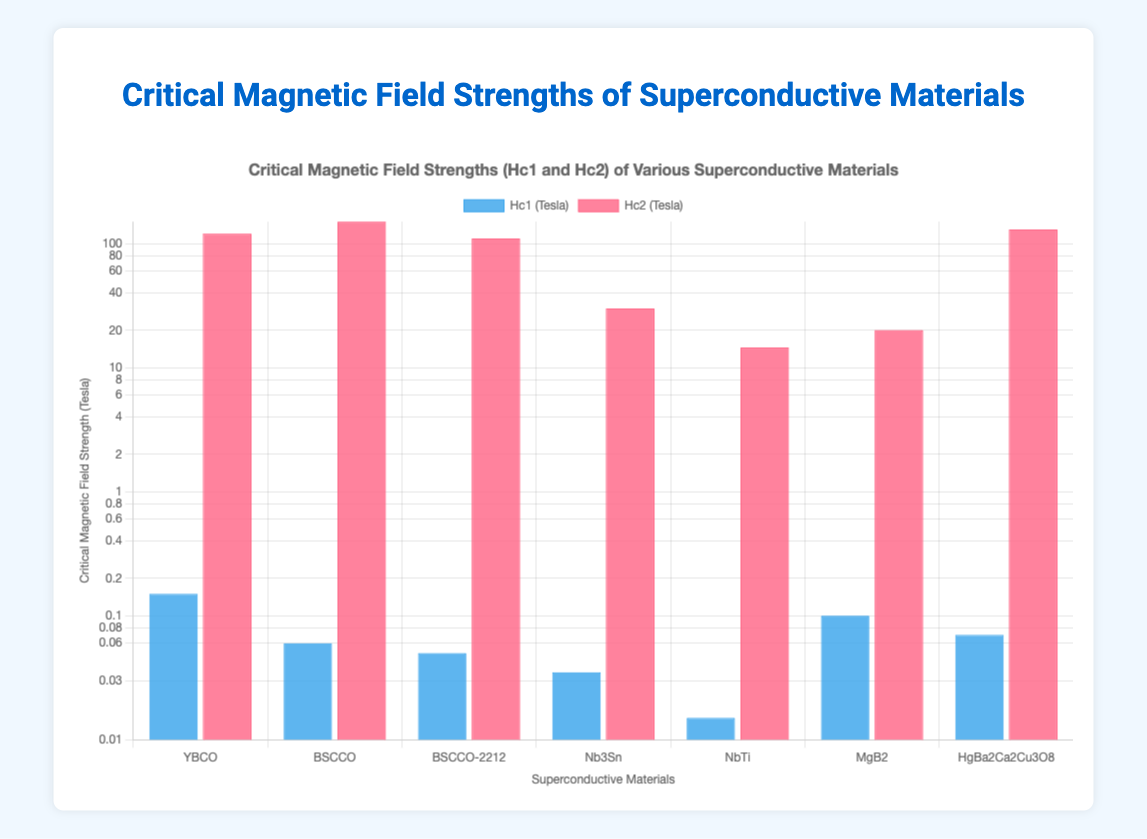How does the Hc1 value of the high-temperature superconductors compare against each other? The Hc1 values for the high-temperature superconductors are YBCO: 0.15, BSCCO: 0.06, BSCCO-2212: 0.05, and HgBa2Ca2Cu3O8: 0.07. By comparison, YBCO has the highest Hc1 value among them, while BSCCO-2212 has the lowest.
Answer: YBCO has the highest Hc1 of 0.15 T, BSCCO-2212 has the lowest Hc1 of 0.05 T Which material shows the largest difference between its Hc1 and Hc2 values? The differences between Hc1 and Hc2 values for each material are: YBCO: 119.85, BSCCO: 149.94, BSCCO-2212: 109.95, Nb3Sn: 29.965, NbTi: 14.485, MgB2: 19.9, HgBa2Ca2Cu3O8: 129.93. BSCCO has the largest difference.
Answer: BSCCO Which superconductive material has the highest Hc2 value and what is its value? The Hc2 values are: YBCO: 120.0, BSCCO: 150.0, BSCCO-2212: 110.0, Nb3Sn: 30.0, NbTi: 14.5, MgB2: 20.0, HgBa2Ca2Cu3O8: 130.0. The highest Hc2 value is for BSCCO.
Answer: BSCCO with 150.0 T For the materials with the lowest Hc1, what are their Hc2 values? The materials with the lowest Hc1 values are NbTi (0.015) and BSCCO-2212 (0.05). Their Hc2 values are NbTi: 14.5 and BSCCO-2212: 110.0.
Answer: NbTi: 14.5 T, BSCCO-2212: 110.0 T Arrange the materials in descending order of their Hc1 values. The Hc1 values are: YBCO: 0.15, MgB2: 0.1, HgBa2Ca2Cu3O8: 0.07, BSCCO: 0.06, BSCCO-2212: 0.05, Nb3Sn: 0.035, NbTi: 0.015. Arranged in descending order: YBCO, MgB2, HgBa2Ca2Cu3O8, BSCCO, BSCCO-2212, Nb3Sn, NbTi.
Answer: YBCO, MgB2, HgBa2Ca2Cu3O8, BSCCO, BSCCO-2212, Nb3Sn, NbTi What is the average Hc2 value for high-temperature superconductors? The Hc2 values for high-temperature superconductors are YBCO: 120.0, BSCCO: 150.0, BSCCO-2212: 110.0, HgBa2Ca2Cu3O8: 130.0. Summing these gives 510.0, and the average is 510.0/4 = 127.5.
Answer: 127.5 T What can be inferred from the bar chart about MgB2's critical magnetic fields relative to other materials? MgB2 has an intermediate Hc1 value (0.1), being higher than all low-temperature superconductors and lower than most high-temperature ones. MgB2's Hc2 value (20.0) is also considerably lower than all high-temperature superconductor's Hc2 values but higher than the low-temperature superconductors.
Answer: Intermediate Hc1 and Hc2 values What material has the closest Hc1 and Hc2 values? The differences between Hc1 and Hc2 are: YBCO: 119.85, BSCCO: 149.94, BSCCO-2212: 109.95, Nb3Sn: 29.965, NbTi: 14.485, MgB2: 19.9, HgBa2Ca2Cu3O8: 129.93. NbTi has the closest values.
Answer: NbTi Compare the range of Hc1 values to Hc2 values for the provided materials. What can you conclude? Hc1 values range from 0.015 to 0.15 (range: 0.135). Hc2 values range from 14.5 to 150.0 (range: 135.5). The Hc2 values have a much larger range and variability compared to Hc1 values.
Answer: Hc2 values have a larger range and variability Which material(s) have an Hc2 value lower than 50 Tesla? The Hc2 values below 50 Tesla are for Nb3Sn (30.0) and NbTi (14.5) only.
Answer: Nb3Sn and NbTi 